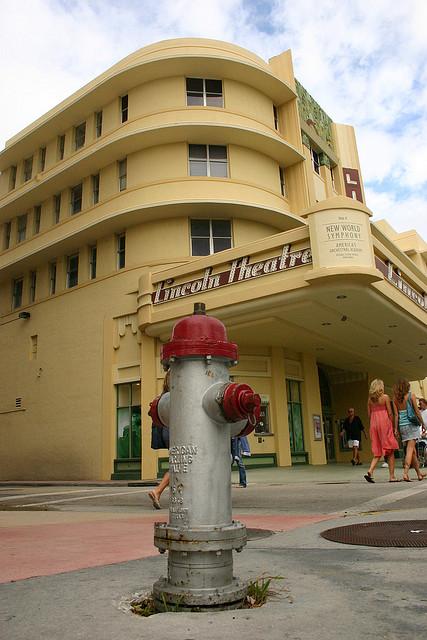What does the print on the says?
Give a very brief answer. Lincoln theatre. How many people are there?
Write a very short answer. 5. What color is the hydrant?
Short answer required. Silver and red. What type of building is across from the hydrant?
Answer briefly. Theater. 